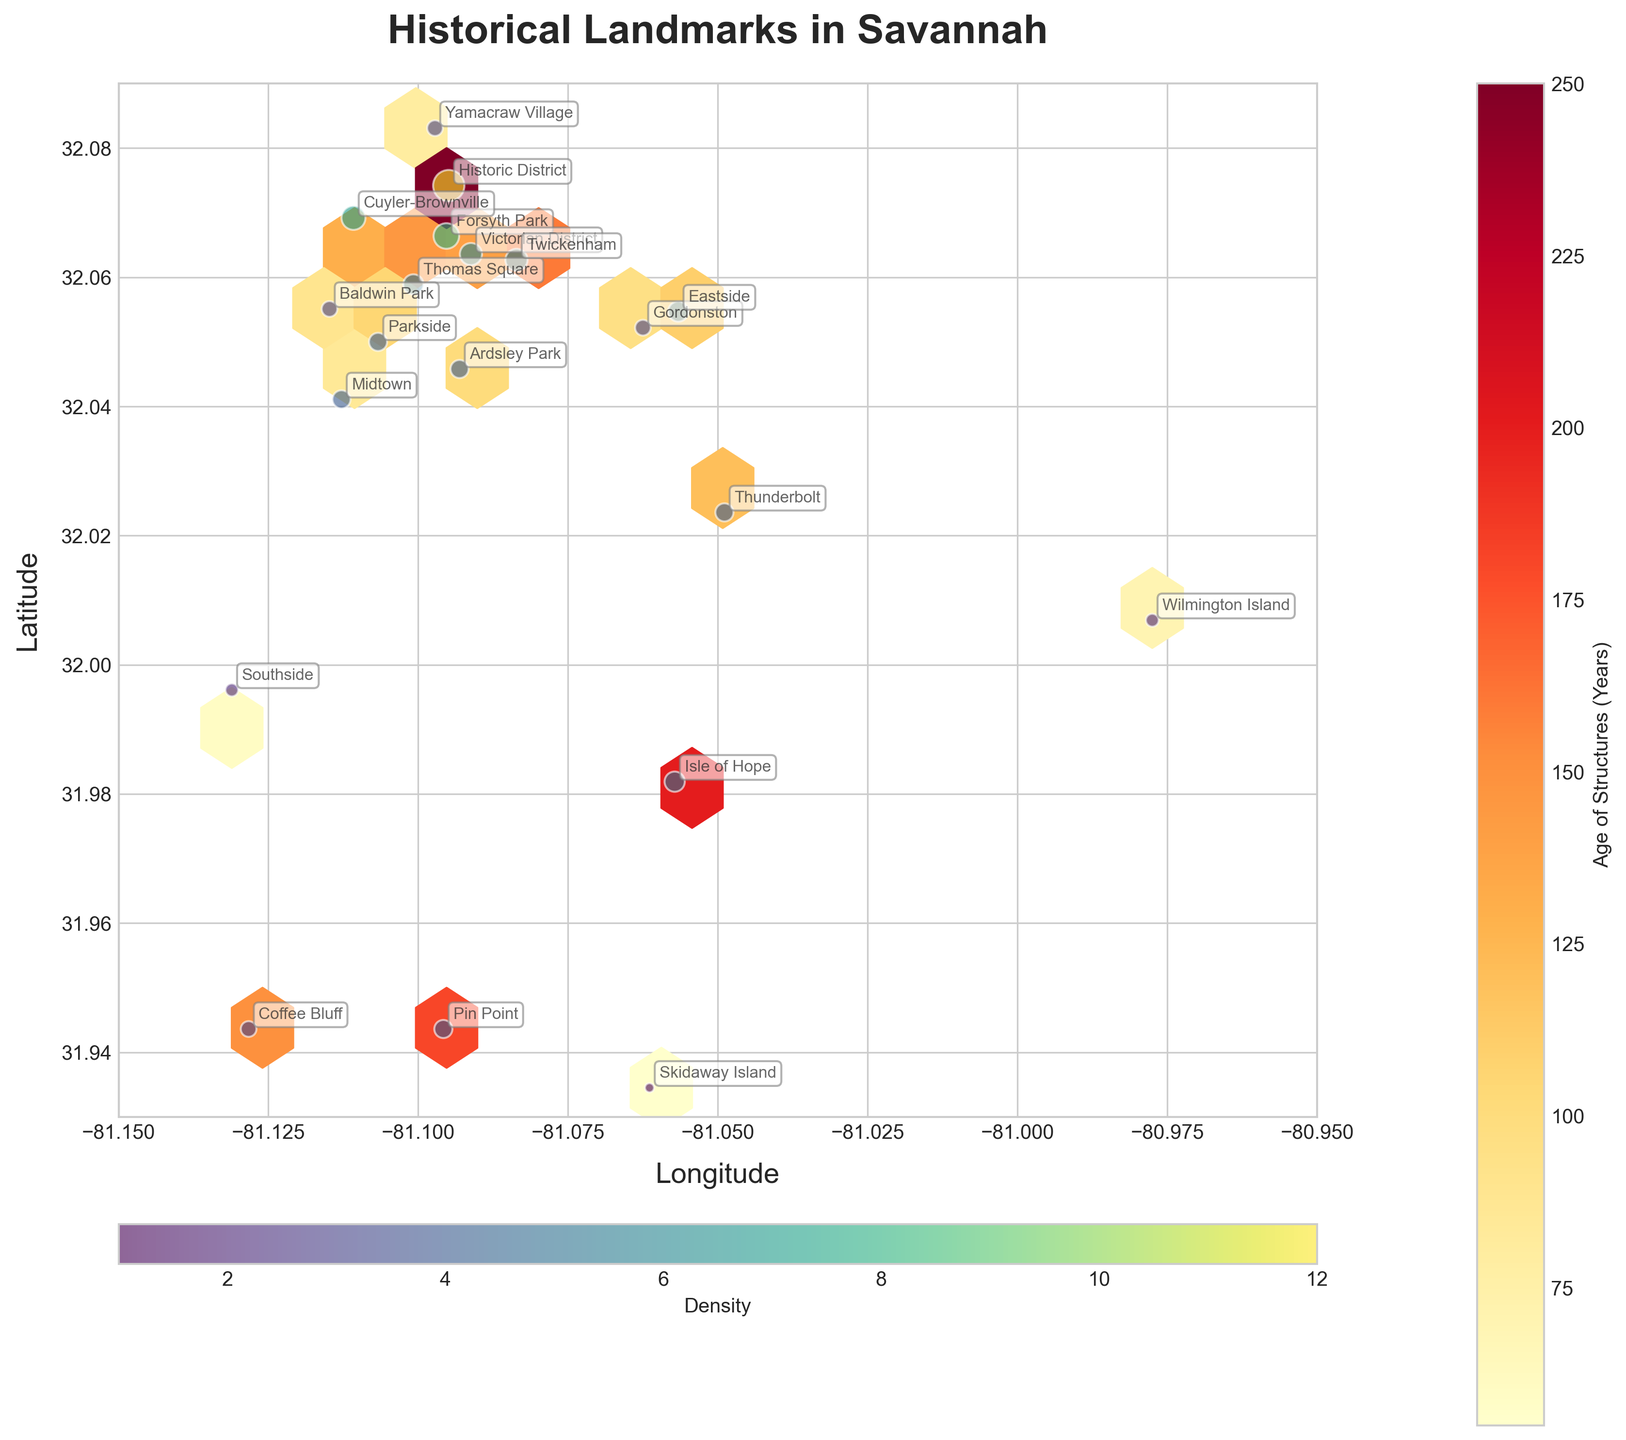What is the title of the plot? The title is positioned at the top of the plot, utilized to give an overall understanding of the plot's content.
Answer: "Historical Landmarks in Savannah" Which district has the highest density of historical landmarks? To find this, look for the district annotated on the plot with the largest scatter point, as density is indicated by the size of the scatter points. The largest scatter point corresponds to the Historic District.
Answer: Historic District What color represents the oldest structures? The colorbar labeled “Age of Structures (Years)” helps to identify the age. Darkest red indicates the oldest structures.
Answer: Dark red What are the latitude and longitude boundaries of the plot? The x-axis and y-axis labels and ticks help to identify the boundaries. The longitude ranges from -81.15 to -80.95 and the latitude ranges from 31.93 to 32.09.
Answer: Longitude: -81.15 to -80.95, Latitude: 31.93 to 32.09 Which district has structures aged 200 years? Use the color indicator on the plot to find the districts with the corresponding color for structures aged around 200 years. Isle of Hope is the district matching this criterion.
Answer: Isle of Hope Which two districts have the closest density values? Look for points of similar size on the scatter plot, which indicates similar density. Midtown and Parkside have closely sized scatter points indicating similar density.
Answer: Midtown and Parkside What district is located at the most southern point on the plot? The southernmost point on the y-axis (latitude) with an annotation will indicate the district name.
Answer: Coffee Bluff How does the density of structures in Forsyth Park compare to Ardsley Park? Find Forsyth Park and Ardsley Park on the scatter plot and compare the sizes of their points. Forsyth Park has a larger point indicating higher density.
Answer: Forsyth Park has a higher density than Ardsley Park Which area has newer structures, Midtown or Cuyler-Brownville? Compare the colors of the points representing Midtown and Cuyler-Brownville; the color gradient tells the age (darker is older). Midtown, with its lighter color, indicates newer structures.
Answer: Midtown 